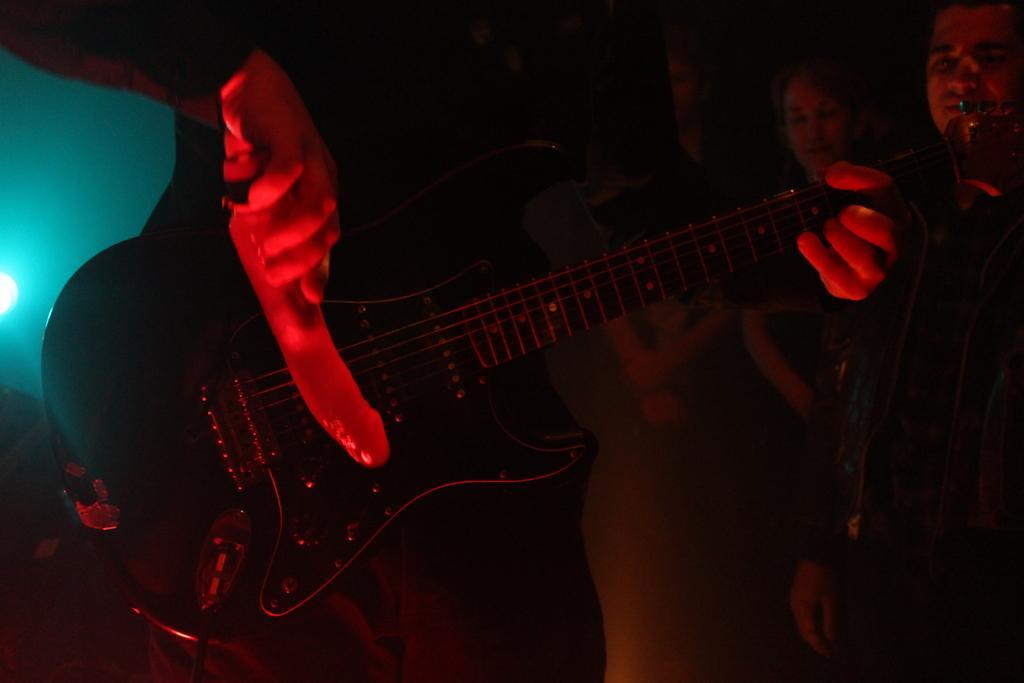Please provide a concise description of this image. A man is playing guitar behind him there are few people. 